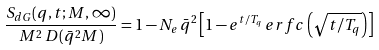<formula> <loc_0><loc_0><loc_500><loc_500>\frac { S _ { d G } ( q , t ; M , \infty ) } { M ^ { 2 } \, D ( \bar { q } ^ { 2 } M ) } = 1 - N _ { e } \, \bar { q } ^ { 2 } \left [ 1 - e ^ { t / T _ { q } } \, e r f c \left ( \sqrt { t / T _ { q } } \right ) \right ]</formula> 